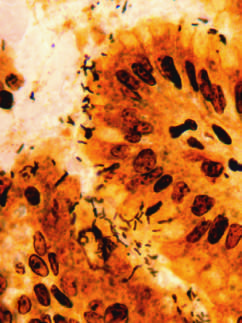re organisms abundant within surface mucus?
Answer the question using a single word or phrase. Yes 